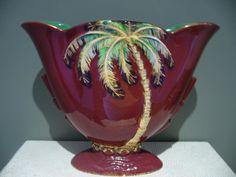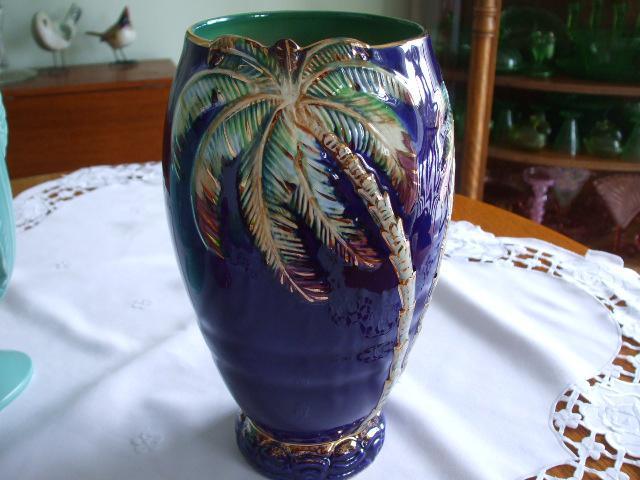The first image is the image on the left, the second image is the image on the right. For the images displayed, is the sentence "There is at least 1 blue decorative vase with a palm tree on it." factually correct? Answer yes or no. Yes. The first image is the image on the left, the second image is the image on the right. Given the left and right images, does the statement "the right image contains a pitcher with a handle" hold true? Answer yes or no. No. 